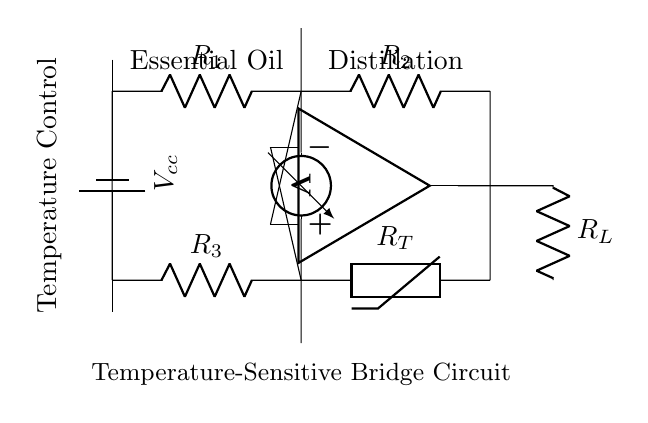What type of circuit is depicted? The circuit is a temperature-sensitive bridge circuit, characterized by its arrangement of resistors and a thermistor to measure temperature changes.
Answer: Temperature-sensitive bridge circuit What component is used for temperature sensing? The component used for temperature sensing in this circuit is a thermistor, which changes resistance with temperature variations.
Answer: Thermistor What does the operational amplifier do in this circuit? The operational amplifier amplifies the voltage difference between the upper and lower sides of the bridge, allowing for precise measurements.
Answer: Amplifies voltage difference Which resistors are part of the bridge? The resistors included in the bridge are R1, R2, and R3, forming a balance with the thermistor to detect temperature changes.
Answer: R1, R2, R3 How is the output taken in this circuit? The output is taken from the operational amplifier, which is connected to the lower side of the bridge circuit.
Answer: From the operational amplifier What is the purpose of the voltmeter in the circuit? The voltmeter measures the voltage across one side of the bridge, providing data on the balance condition and temperature reading.
Answer: Measure voltage 